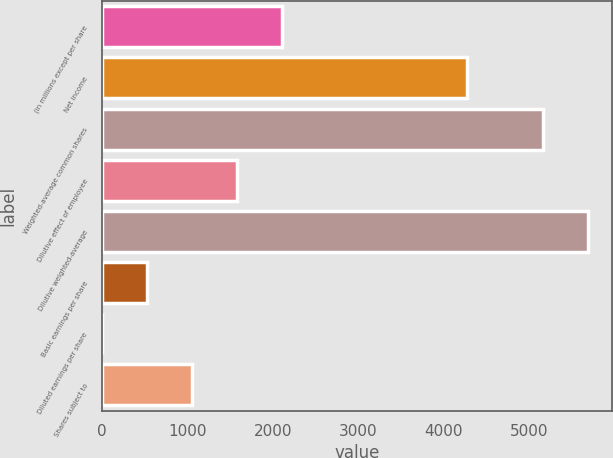<chart> <loc_0><loc_0><loc_500><loc_500><bar_chart><fcel>(in millions except per share<fcel>Net income<fcel>Weighted-average common shares<fcel>Dilutive effect of employee<fcel>Dilutive weighted-average<fcel>Basic earnings per share<fcel>Diluted earnings per share<fcel>Shares subject to<nl><fcel>2108.09<fcel>4274<fcel>5170<fcel>1581.27<fcel>5696.82<fcel>527.63<fcel>0.81<fcel>1054.45<nl></chart> 